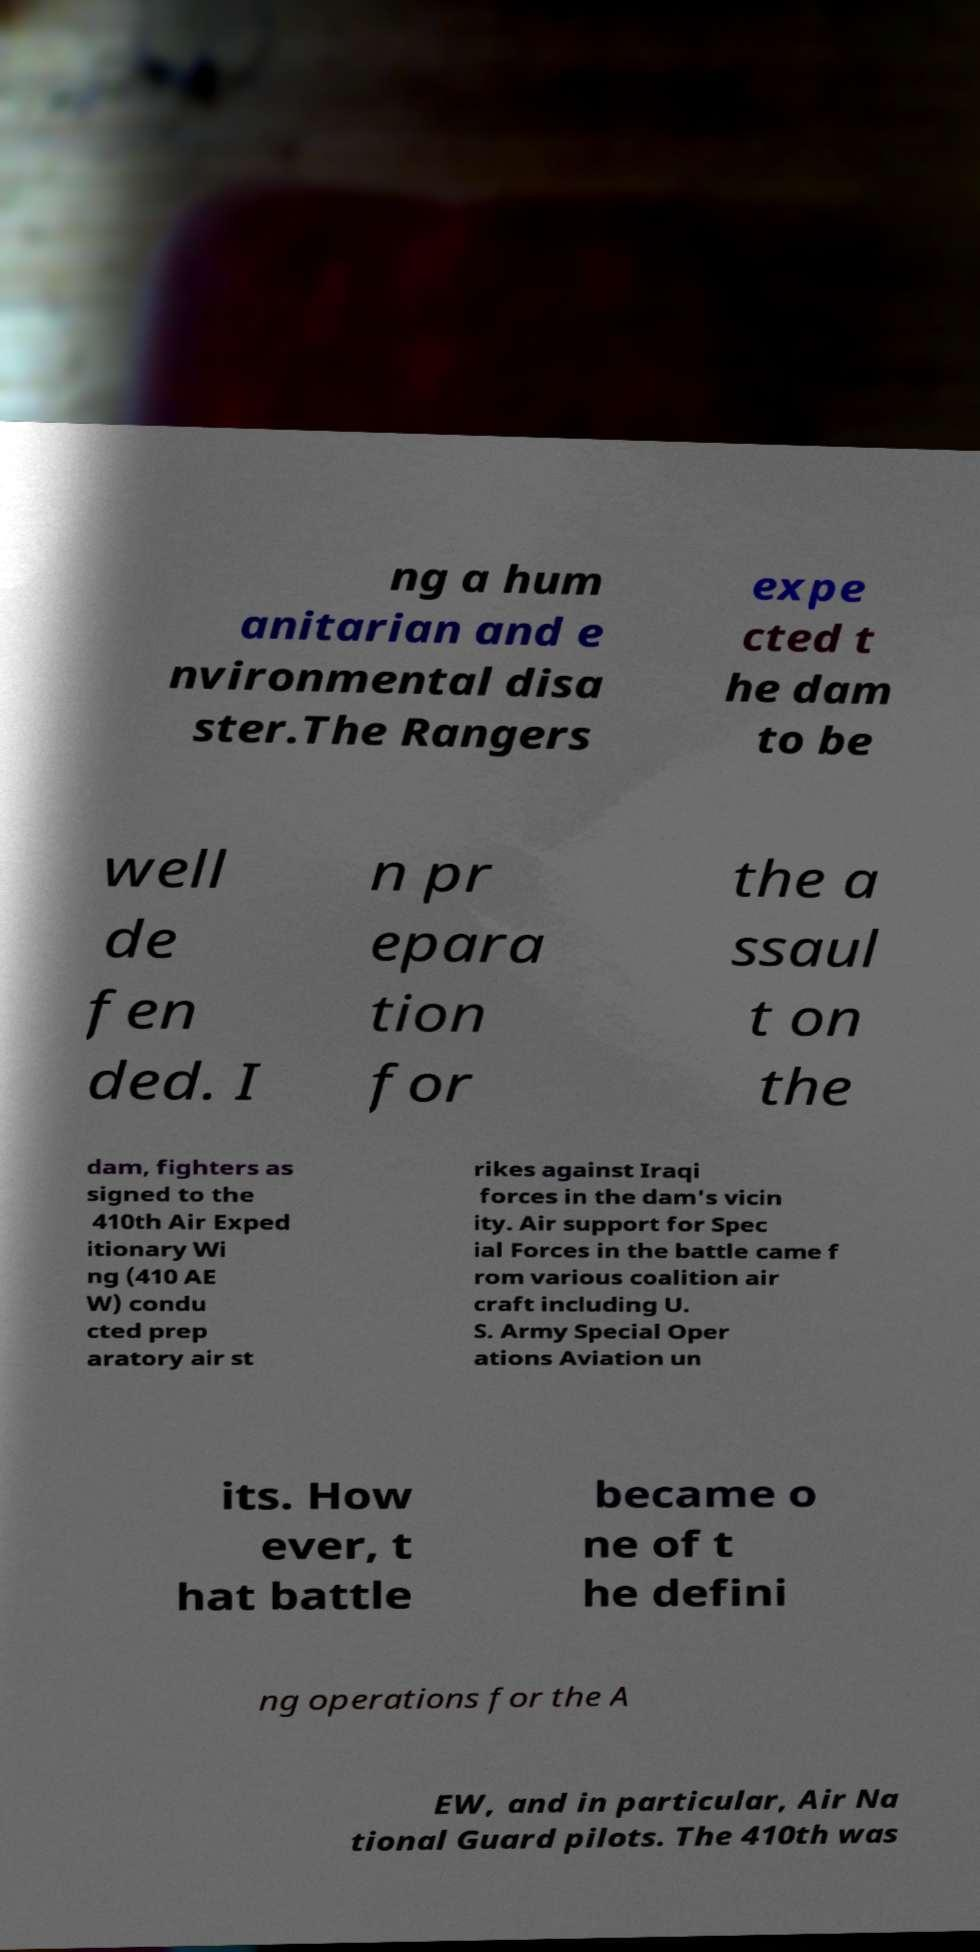Can you read and provide the text displayed in the image?This photo seems to have some interesting text. Can you extract and type it out for me? ng a hum anitarian and e nvironmental disa ster.The Rangers expe cted t he dam to be well de fen ded. I n pr epara tion for the a ssaul t on the dam, fighters as signed to the 410th Air Exped itionary Wi ng (410 AE W) condu cted prep aratory air st rikes against Iraqi forces in the dam's vicin ity. Air support for Spec ial Forces in the battle came f rom various coalition air craft including U. S. Army Special Oper ations Aviation un its. How ever, t hat battle became o ne of t he defini ng operations for the A EW, and in particular, Air Na tional Guard pilots. The 410th was 